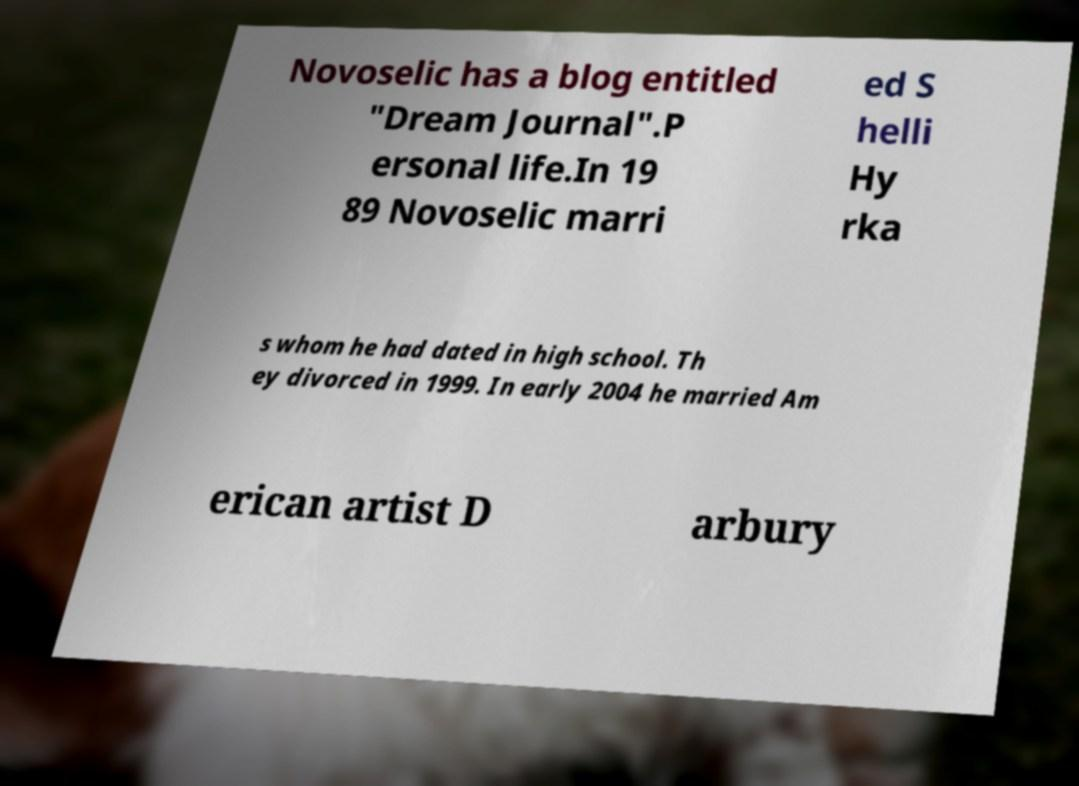Can you read and provide the text displayed in the image?This photo seems to have some interesting text. Can you extract and type it out for me? Novoselic has a blog entitled "Dream Journal".P ersonal life.In 19 89 Novoselic marri ed S helli Hy rka s whom he had dated in high school. Th ey divorced in 1999. In early 2004 he married Am erican artist D arbury 